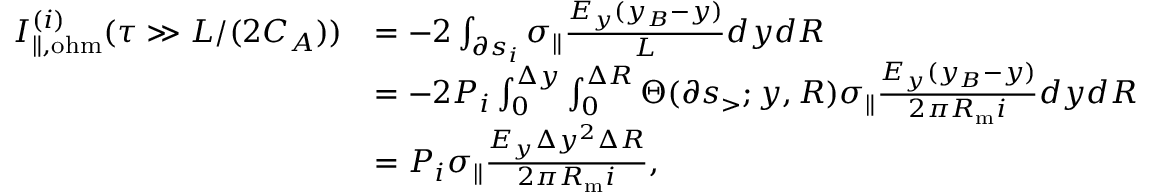<formula> <loc_0><loc_0><loc_500><loc_500>\begin{array} { r l } { I _ { \| , o h m } ^ { ( i ) } ( \tau \gg L / ( 2 C _ { A } ) ) } & { = - 2 \int _ { \partial s _ { i } } \sigma _ { \| } \frac { E _ { y } ( y _ { B } - y ) } { L } d y d R } \\ & { = - 2 P _ { i } \int _ { 0 } ^ { \Delta y } \int _ { 0 } ^ { \Delta R } \Theta ( \partial s _ { > } ; y , R ) \sigma _ { \| } \frac { E _ { y } ( y _ { B } - y ) } { 2 \pi R _ { m } i } d y d R } \\ & { = P _ { i } \sigma _ { \| } \frac { E _ { y } \Delta y ^ { 2 } \Delta R } { 2 \pi R _ { m } i } , } \end{array}</formula> 